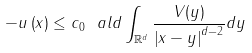Convert formula to latex. <formula><loc_0><loc_0><loc_500><loc_500>- u \left ( x \right ) \leq c _ { 0 } \ a l d \int _ { \mathbb { R } ^ { d } } { \frac { V ( y ) } { \left | x - y \right | ^ { d - 2 } } d y }</formula> 